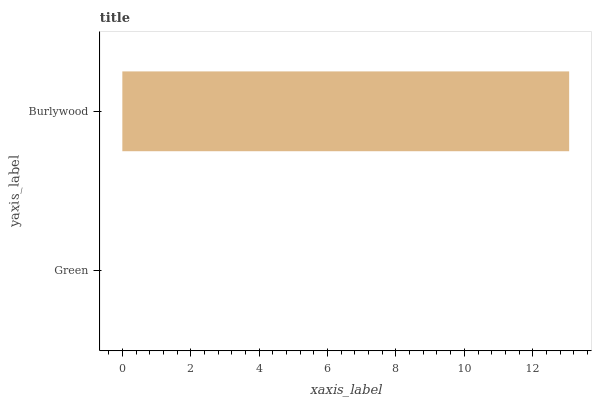Is Green the minimum?
Answer yes or no. Yes. Is Burlywood the maximum?
Answer yes or no. Yes. Is Burlywood the minimum?
Answer yes or no. No. Is Burlywood greater than Green?
Answer yes or no. Yes. Is Green less than Burlywood?
Answer yes or no. Yes. Is Green greater than Burlywood?
Answer yes or no. No. Is Burlywood less than Green?
Answer yes or no. No. Is Burlywood the high median?
Answer yes or no. Yes. Is Green the low median?
Answer yes or no. Yes. Is Green the high median?
Answer yes or no. No. Is Burlywood the low median?
Answer yes or no. No. 